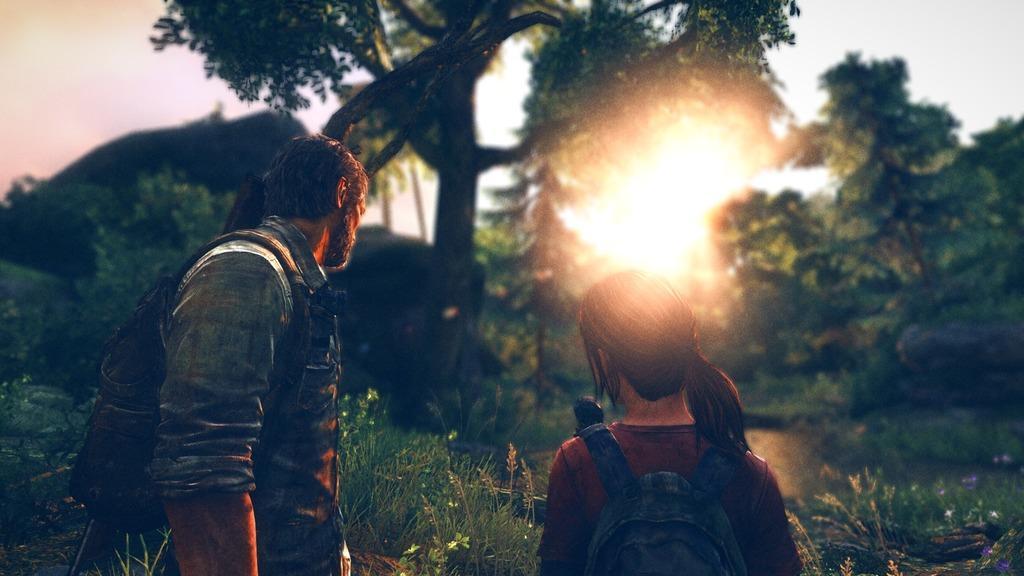How would you summarize this image in a sentence or two? In this image I can see two people. In the background, I can see the trees and the sunrise. 